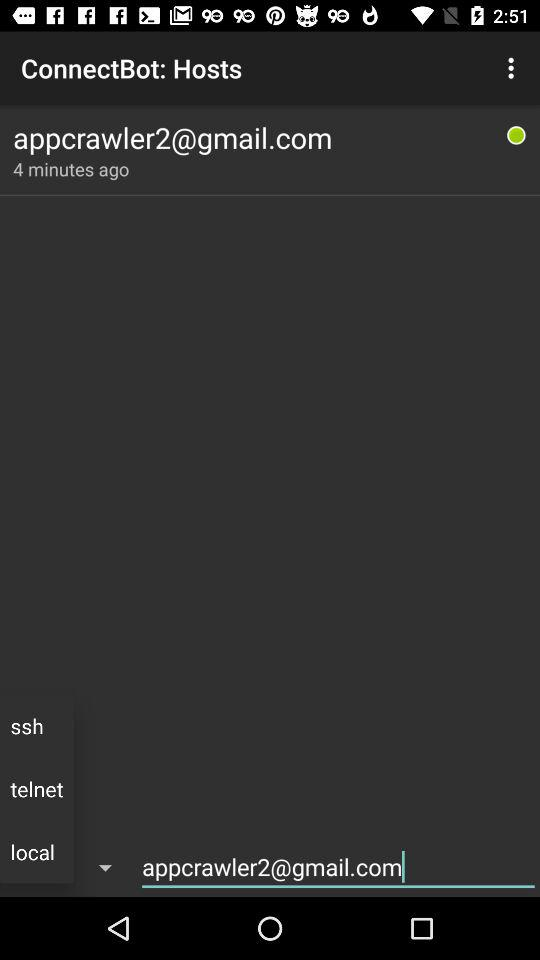What is the email address? The email address is appcrawler2@gmail.com. 